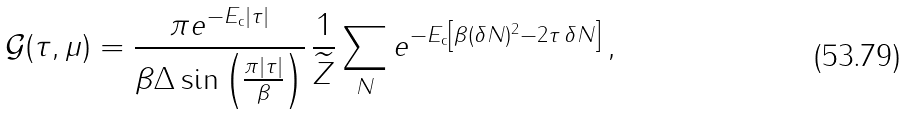Convert formula to latex. <formula><loc_0><loc_0><loc_500><loc_500>\mathcal { G } ( \tau , \mu ) & = \frac { { \pi } e ^ { - E _ { \text {c} } | \tau | } } { { \beta \Delta } \sin \left ( \frac { \pi | \tau | } { \beta } \right ) } \, \frac { 1 } { \widetilde { Z } } \sum _ { N } e ^ { - E _ { \text {c} } \left [ \beta ( { \delta N } ) ^ { 2 } - 2 \tau \, \delta N \right ] } \, ,</formula> 